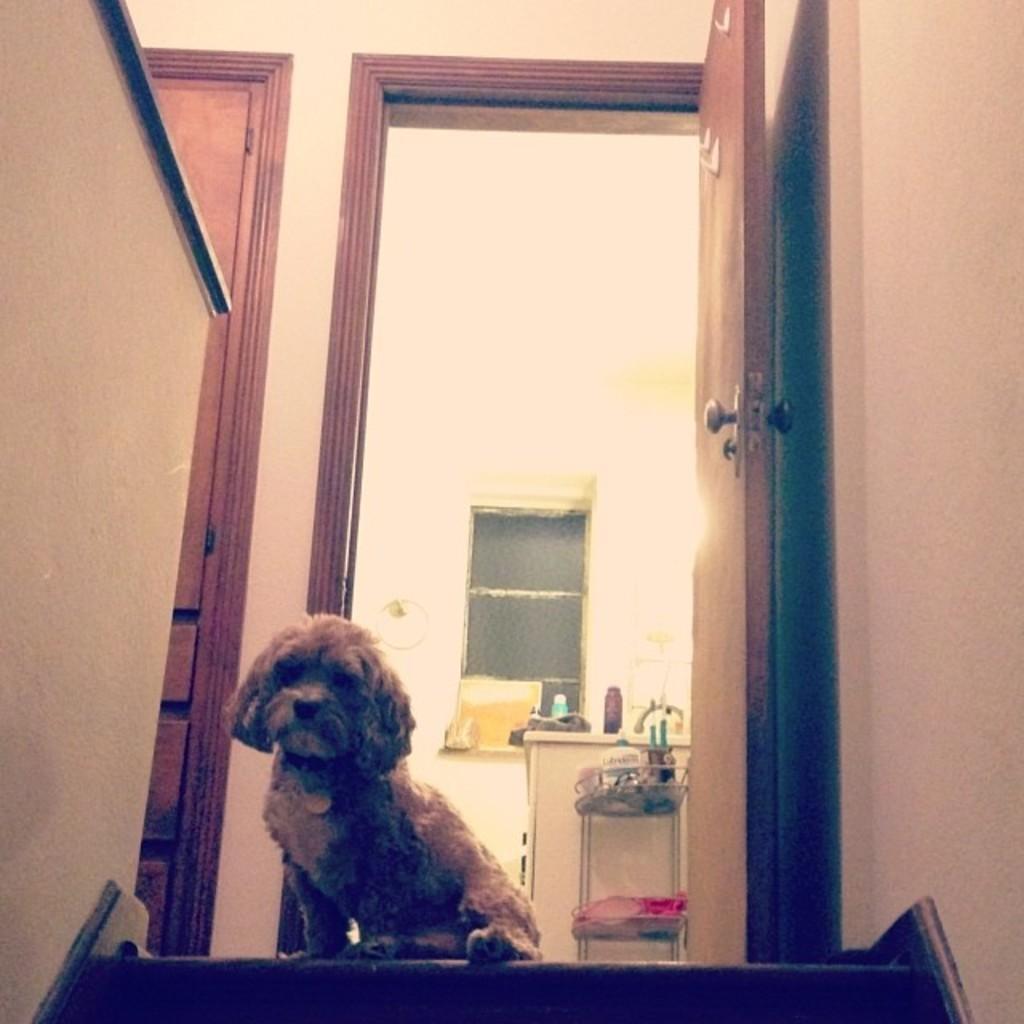Describe this image in one or two sentences. In the foreground of this picture we can see a dog seems to be sitting on the floor and we can see the wooden doors and in the background we can see the wall, window, bottles, table and many other objects. 